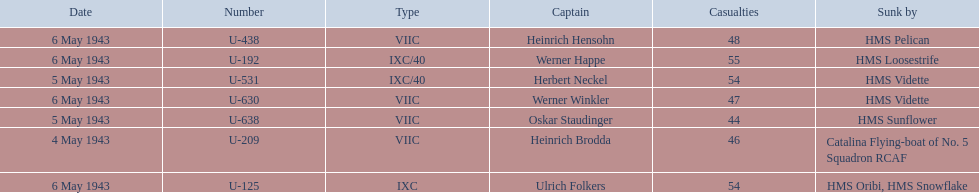What is the only vessel to sink multiple u-boats? HMS Vidette. 